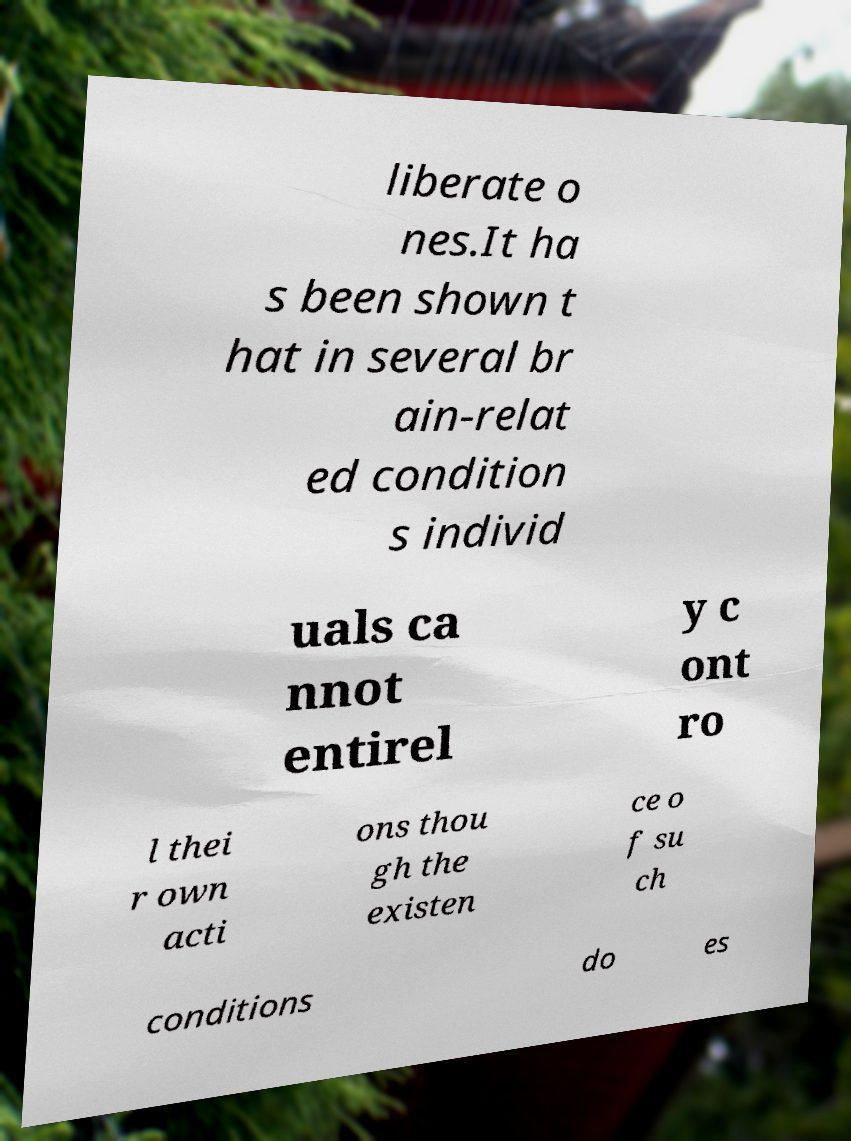For documentation purposes, I need the text within this image transcribed. Could you provide that? liberate o nes.It ha s been shown t hat in several br ain-relat ed condition s individ uals ca nnot entirel y c ont ro l thei r own acti ons thou gh the existen ce o f su ch conditions do es 